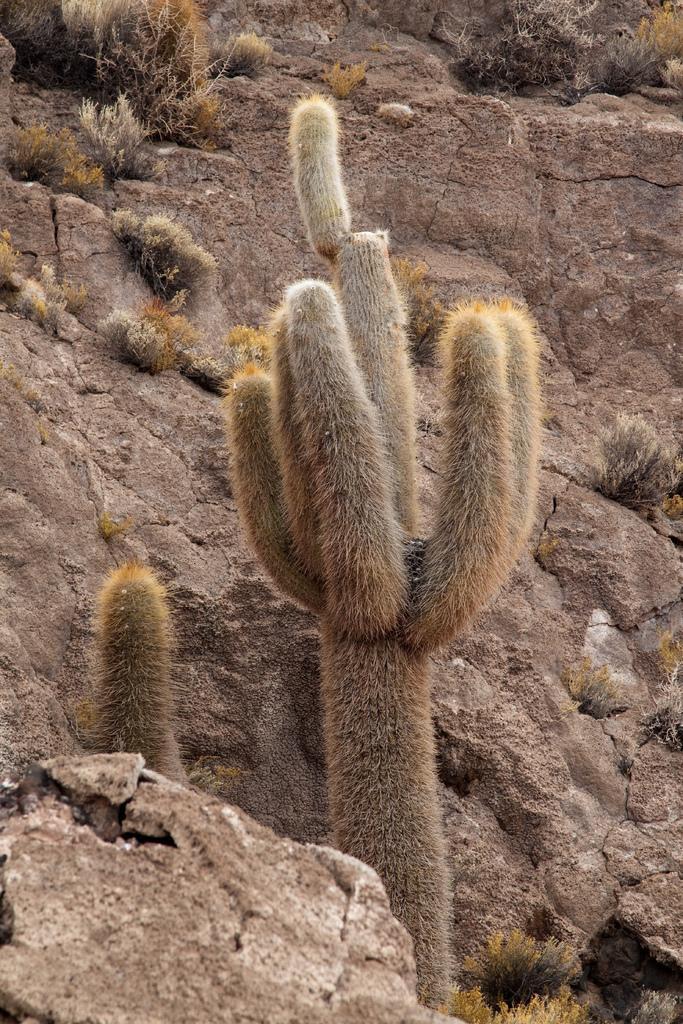Describe this image in one or two sentences. This picture is clicked outside and we can see the cactus plants and some other plants and we can see the rocks and some other objects. 